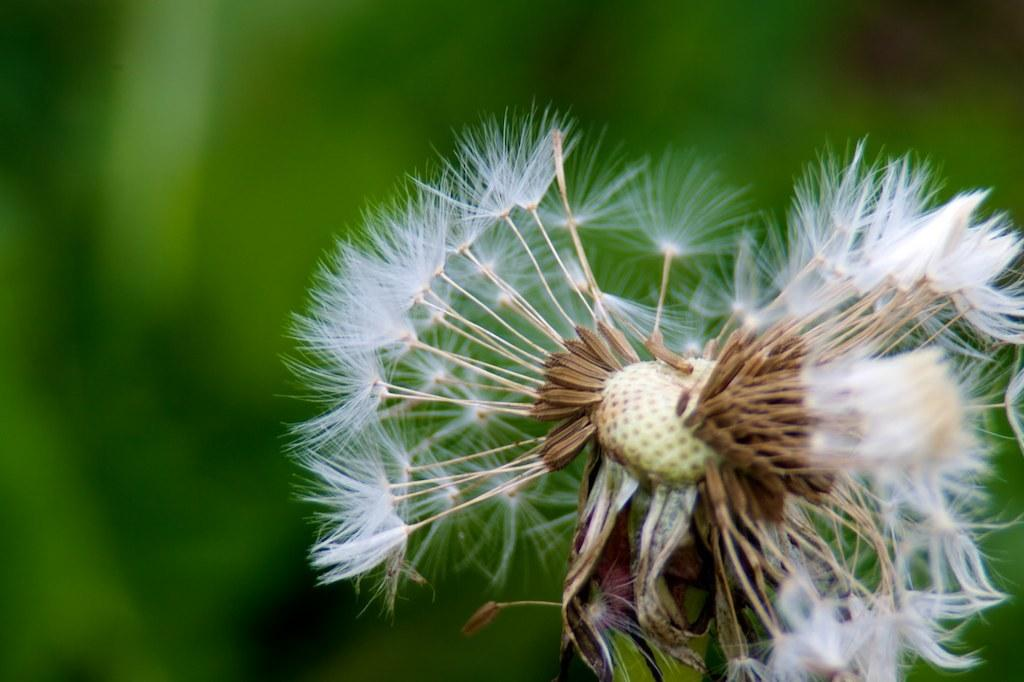What is the main subject in the foreground of the image? There is a flower in the foreground of the image. What can be observed about the background of the image? The background of the image is blurred. What type of clouds can be seen in the image? There are no clouds present in the image; it features a flower in the foreground and a blurred background. 